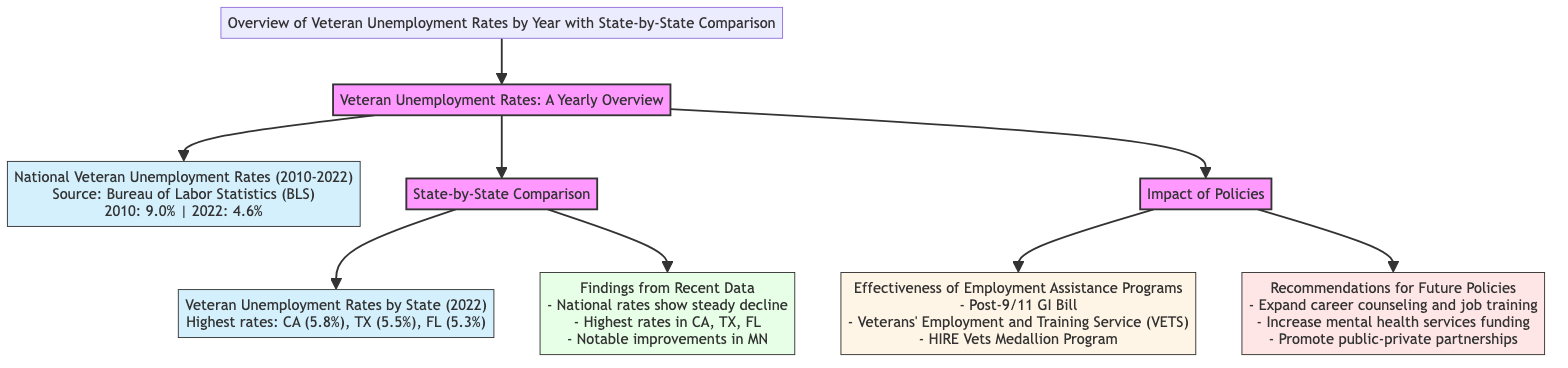What was the national veteran unemployment rate in 2010? The diagram states that the national veteran unemployment rate in 2010 was 9.0%. This value is retrieved directly from the data presented under the "National Veteran Unemployment Rates" section.
Answer: 9.0% What is the veteran unemployment rate in California for 2022? According to the diagram, California has the highest veteran unemployment rate in 2022, which is 5.8%. This information is found in the "Veteran Unemployment Rates by State" section.
Answer: 5.8% How many years of data are shown in the national rates overview? The diagram indicates that national veteran unemployment rates are shown from 2010 to 2022, which spans 13 years. This is deduced by counting the years from the starting value (2010) to the ending value (2022).
Answer: 13 Which state showed notable improvements in veteran unemployment rates? The diagram mentions Minnesota (MN) as having notable improvements in veteran unemployment rates. This information is highlighted in the "Findings from Recent Data" section.
Answer: Minnesota What are two programs mentioned that assist with veteran employment? The diagram lists the Post-9/11 GI Bill and the Veterans' Employment and Training Service (VETS) as programs that assist with veteran employment. This can be found in the "Effectiveness of Employment Assistance Programs" section.
Answer: Post-9/11 GI Bill, Veterans' Employment and Training Service (VETS) How many states have unemployment rates over 5% according to the diagram? The diagram presents specific rates for CA (5.8%), TX (5.5%), and FL (5.3%), which indicates that there are three states with unemployment rates over 5%. This is determined by counting the states listed with rates exceeding that percentage.
Answer: 3 What is the recommendation for future policies regarding mental health services? One of the recommendations for future policies presented in the diagram is to increase mental health services funding. This information is included in the "Recommendations for Future Policies" section.
Answer: Increase mental health services funding What primary source provided the data for the national veteran unemployment rates? The diagram attributes the national veteran unemployment rates data to the Bureau of Labor Statistics (BLS). This is specified directly under the national rates information.
Answer: Bureau of Labor Statistics (BLS) 